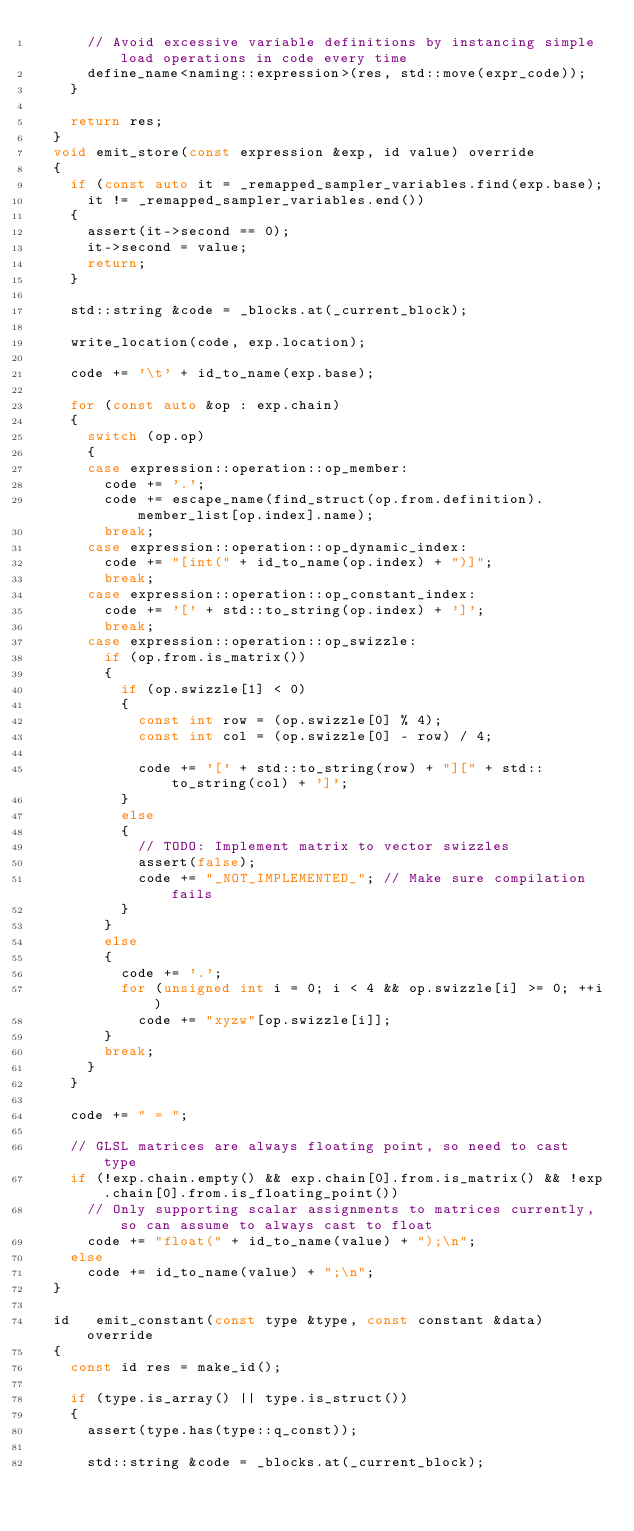Convert code to text. <code><loc_0><loc_0><loc_500><loc_500><_C++_>			// Avoid excessive variable definitions by instancing simple load operations in code every time
			define_name<naming::expression>(res, std::move(expr_code));
		}

		return res;
	}
	void emit_store(const expression &exp, id value) override
	{
		if (const auto it = _remapped_sampler_variables.find(exp.base);
			it != _remapped_sampler_variables.end())
		{
			assert(it->second == 0);
			it->second = value;
			return;
		}

		std::string &code = _blocks.at(_current_block);

		write_location(code, exp.location);

		code += '\t' + id_to_name(exp.base);

		for (const auto &op : exp.chain)
		{
			switch (op.op)
			{
			case expression::operation::op_member:
				code += '.';
				code += escape_name(find_struct(op.from.definition).member_list[op.index].name);
				break;
			case expression::operation::op_dynamic_index:
				code += "[int(" + id_to_name(op.index) + ")]";
				break;
			case expression::operation::op_constant_index:
				code += '[' + std::to_string(op.index) + ']';
				break;
			case expression::operation::op_swizzle:
				if (op.from.is_matrix())
				{
					if (op.swizzle[1] < 0)
					{
						const int row = (op.swizzle[0] % 4);
						const int col = (op.swizzle[0] - row) / 4;

						code += '[' + std::to_string(row) + "][" + std::to_string(col) + ']';
					}
					else
					{
						// TODO: Implement matrix to vector swizzles
						assert(false);
						code += "_NOT_IMPLEMENTED_"; // Make sure compilation fails
					}
				}
				else
				{
					code += '.';
					for (unsigned int i = 0; i < 4 && op.swizzle[i] >= 0; ++i)
						code += "xyzw"[op.swizzle[i]];
				}
				break;
			}
		}

		code += " = ";

		// GLSL matrices are always floating point, so need to cast type
		if (!exp.chain.empty() && exp.chain[0].from.is_matrix() && !exp.chain[0].from.is_floating_point())
			// Only supporting scalar assignments to matrices currently, so can assume to always cast to float
			code += "float(" + id_to_name(value) + ");\n";
		else
			code += id_to_name(value) + ";\n";
	}

	id   emit_constant(const type &type, const constant &data) override
	{
		const id res = make_id();

		if (type.is_array() || type.is_struct())
		{
			assert(type.has(type::q_const));

			std::string &code = _blocks.at(_current_block);
</code> 